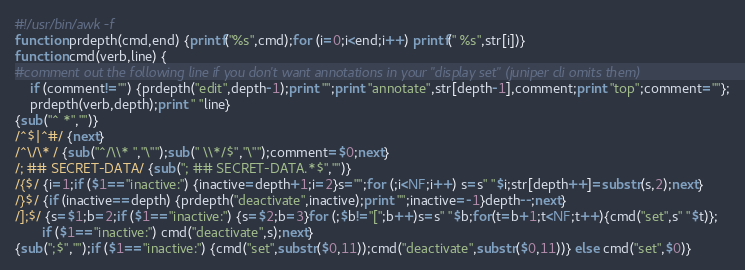Convert code to text. <code><loc_0><loc_0><loc_500><loc_500><_Awk_>#!/usr/bin/awk -f
function prdepth(cmd,end) {printf("%s",cmd);for (i=0;i<end;i++) printf(" %s",str[i])}
function cmd(verb,line) {
#comment out the following line if you don't want annotations in your "display set" (juniper cli omits them)
    if (comment!="") {prdepth("edit",depth-1);print "";print "annotate",str[depth-1],comment;print "top";comment=""};
    prdepth(verb,depth);print " "line}
{sub("^ *","")}
/^$|^#/ {next}
/^\/\* / {sub("^/\\* ","\"");sub(" \\*/$","\"");comment=$0;next}
/; ## SECRET-DATA/ {sub("; ## SECRET-DATA.*$","")}
/{$/ {i=1;if ($1=="inactive:") {inactive=depth+1;i=2}s="";for (;i<NF;i++) s=s" "$i;str[depth++]=substr(s,2);next}
/}$/ {if (inactive==depth) {prdepth("deactivate",inactive);print "";inactive=-1}depth--;next}
/];$/ {s=$1;b=2;if ($1=="inactive:") {s=$2;b=3}for (;$b!="[";b++)s=s" "$b;for(t=b+1;t<NF;t++){cmd("set",s" "$t)};
       if ($1=="inactive:") cmd("deactivate",s);next}
{sub(";$","");if ($1=="inactive:") {cmd("set",substr($0,11));cmd("deactivate",substr($0,11))} else cmd("set",$0)}
</code> 